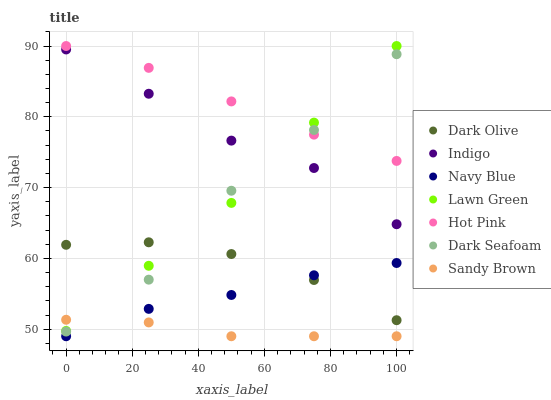Does Sandy Brown have the minimum area under the curve?
Answer yes or no. Yes. Does Hot Pink have the maximum area under the curve?
Answer yes or no. Yes. Does Dark Olive have the minimum area under the curve?
Answer yes or no. No. Does Dark Olive have the maximum area under the curve?
Answer yes or no. No. Is Hot Pink the smoothest?
Answer yes or no. Yes. Is Dark Seafoam the roughest?
Answer yes or no. Yes. Is Dark Olive the smoothest?
Answer yes or no. No. Is Dark Olive the roughest?
Answer yes or no. No. Does Navy Blue have the lowest value?
Answer yes or no. Yes. Does Dark Olive have the lowest value?
Answer yes or no. No. Does Hot Pink have the highest value?
Answer yes or no. Yes. Does Dark Olive have the highest value?
Answer yes or no. No. Is Dark Olive less than Indigo?
Answer yes or no. Yes. Is Hot Pink greater than Dark Olive?
Answer yes or no. Yes. Does Dark Olive intersect Lawn Green?
Answer yes or no. Yes. Is Dark Olive less than Lawn Green?
Answer yes or no. No. Is Dark Olive greater than Lawn Green?
Answer yes or no. No. Does Dark Olive intersect Indigo?
Answer yes or no. No. 